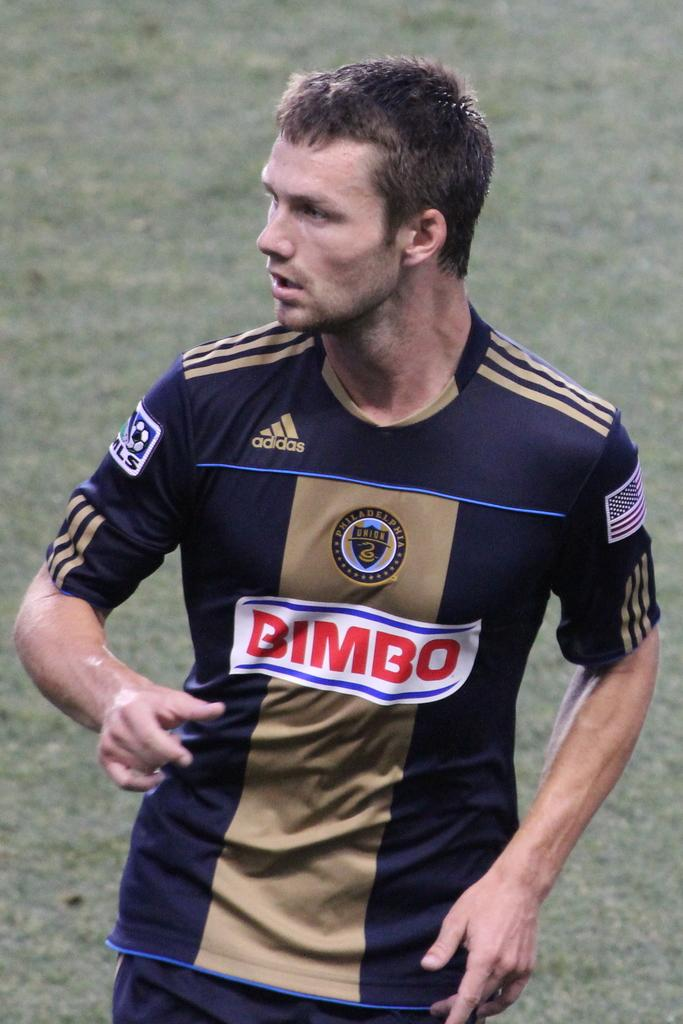Provide a one-sentence caption for the provided image. A man is wearing a jersey with the adidas logo on it. 